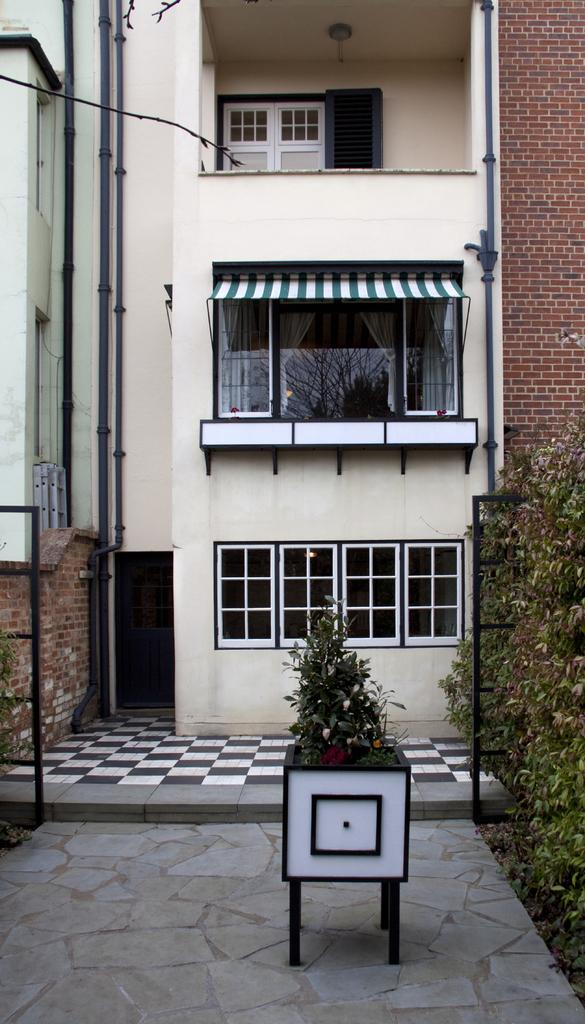What type of structure is in the image? There is a small house in the image. What feature does the house have? The house has a glass balcony. Does the house have any openings for light and ventilation? Yes, the house has a window. What can be seen near the front of the house? There is a small white flower pot in front of the house. What type of flooring is visible in the image? The ground has flooring tiles. What is the house protesting in the image? There is no indication in the image that the house is protesting anything. What act does the house perform in the image? The house is an inanimate object and does not perform any acts. 